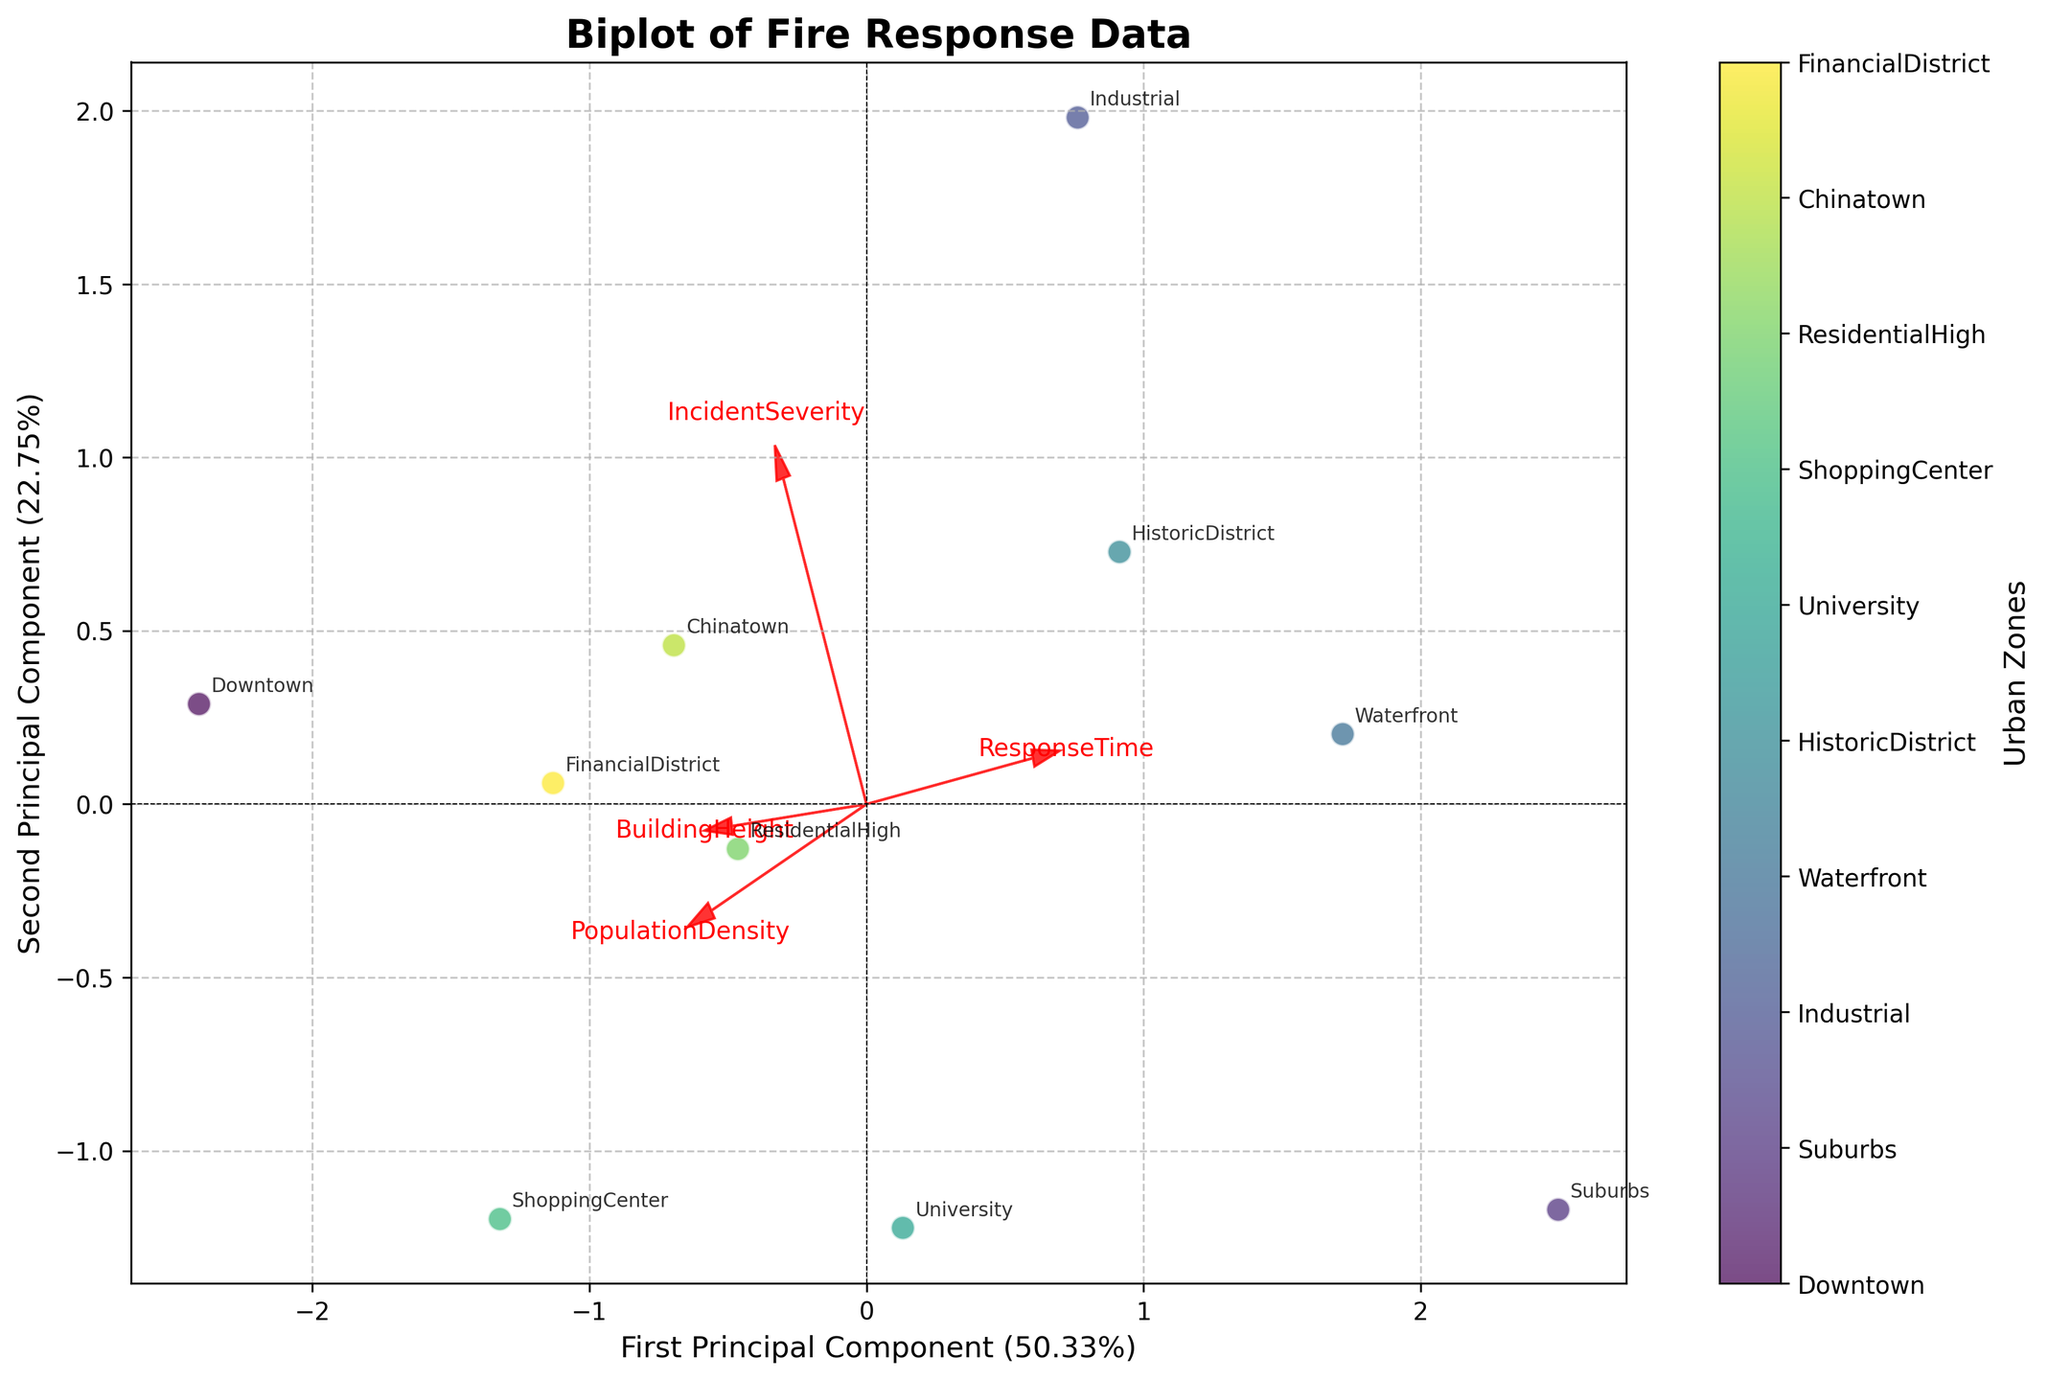What is the title of the biplot? The title of the plot is prominently displayed at the top of the figure.
Answer: Biplot of Fire Response Data How many urban zones are represented in the biplot? Each point in the scatter plot represents a different urban zone. The color legend, as indicated by the colorbar, shows a different color for each zone. By counting the unique labels, we can determine the number of zones.
Answer: 10 Which variables are plotted as arrows in the biplot? The arrows in the biplot represent the feature loadings of the variables. These are labelled at the arrow tips. By looking at the labels at the end of each arrow, we identify the variables.
Answer: ResponseTime, IncidentSeverity, PopulationDensity, BuildingHeight Which zone has the shortest response time based on the plot? The shortest response time is represented by the position of the zone in the direction of the 'ResponseTime' arrow. The point closest to the arrow in the opposite direction of the high response time tip will indicate the shortest response time.
Answer: ShoppingCenter Which variable seems to have the most impact on the first principal component? The length of the arrow in the direction of the first principal component indicates the impact of the variable. The longest arrow in this direction has the most influence.
Answer: PopulationDensity Which two zones appear to have similar response times and incident severity? Zones with similar response times and incident severity will appear close to each other on the plot in the directions corresponding to these variables. By visually assessing the proximity of points in these directions, we identify the similar zones.
Answer: HistoricDistrict and Chinatown What is the approximate percentage of variance explained by the first principal component? This information is given in the x-axis label which describes the first principal component. We can read the explained variance percentage there.
Answer: 42% Which zones are associated with the highest incident severity? We look along the direction pointed by the 'IncidentSeverity' arrow. The zones furthest in that direction are associated with the highest incident severity.
Answer: Industrial and Downtown In which direction would you find zones with tall buildings? The 'BuildingHeight' arrow indicates the direction in which zones with tall buildings would be found. The direction of this arrow shows the increasing trend of building heights.
Answer: Northeast (or positive x and y direction) If we compare Downtown and Industrial, which one has higher response time and why? We can compare the locations of these zones relative to the 'ResponseTime' arrow. The zone further in the direction of this arrow has higher response times.
Answer: Industrial; Industrial is further in the direction of the 'ResponseTime' arrow than Downtown 